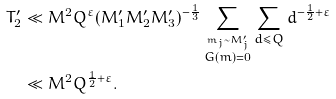<formula> <loc_0><loc_0><loc_500><loc_500>T ^ { \prime } _ { 2 } & \ll M ^ { 2 } Q ^ { \varepsilon } ( M ^ { \prime } _ { 1 } M ^ { \prime } _ { 2 } M ^ { \prime } _ { 3 } ) ^ { - \frac { 1 } { 3 } } \sum _ { \stackrel { m _ { j } \sim M ^ { \prime } _ { j } } { G ( m ) = 0 } } \sum _ { d \leq Q } d ^ { - \frac { 1 } { 2 } + \varepsilon } \\ & \ll M ^ { 2 } Q ^ { \frac { 1 } { 2 } + \varepsilon } .</formula> 